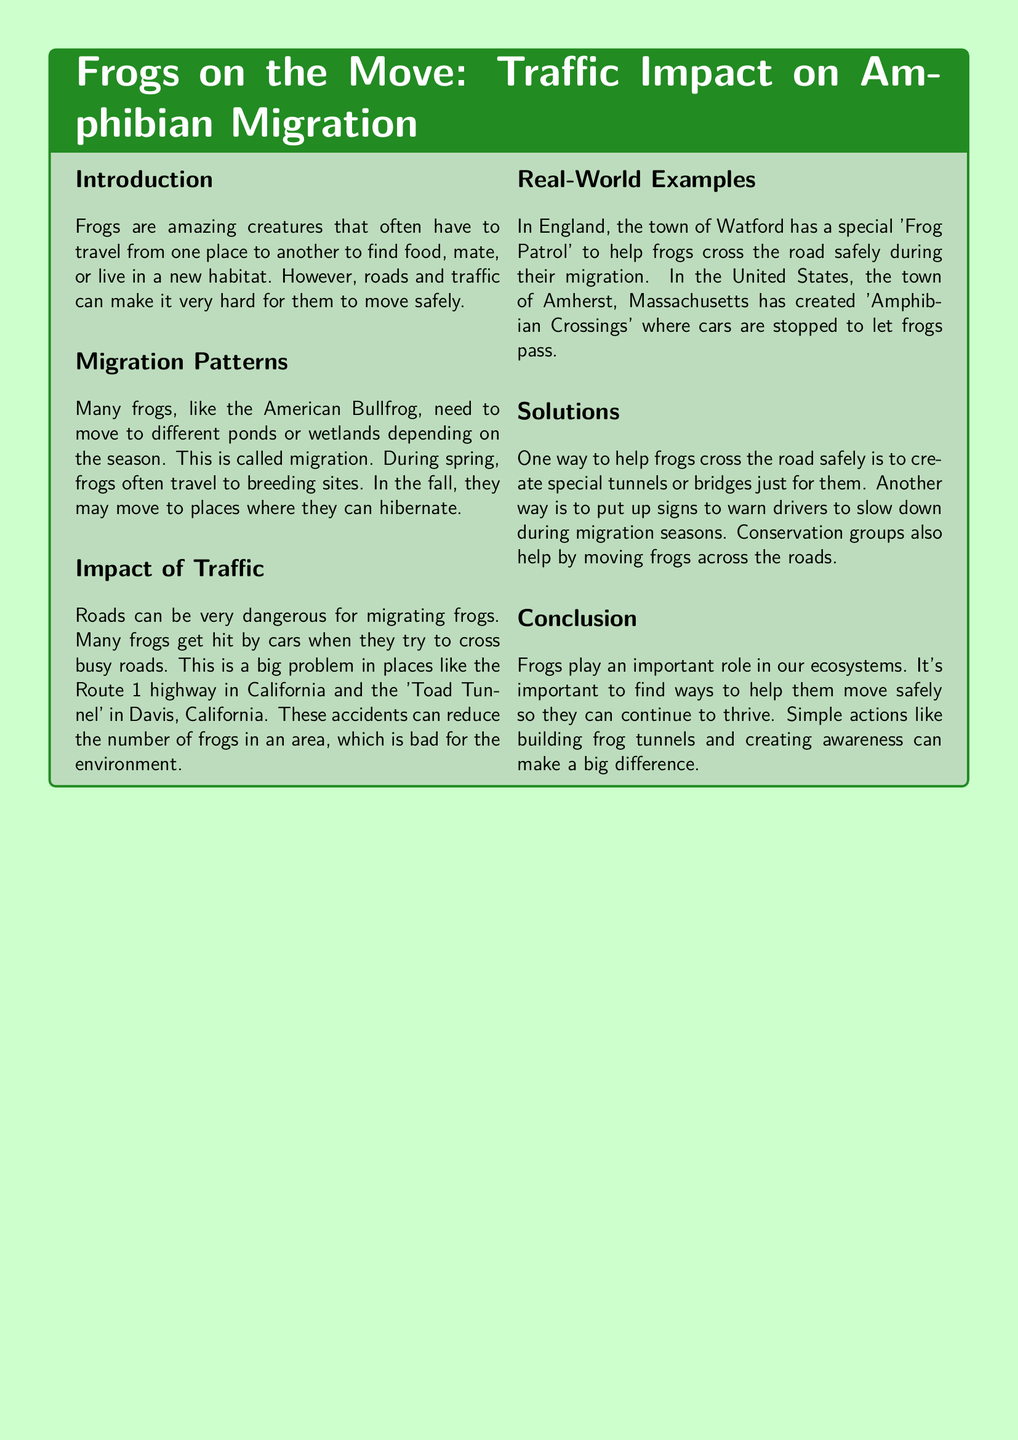what is the title of the report? The title of the report is explicitly stated in the document's header as "Frogs on the Move: Traffic Impact on Amphibian Migration."
Answer: Frogs on the Move: Traffic Impact on Amphibian Migration what do frogs need to find during their migration? The document mentions that frogs often need to find food, mate, or live in a new habitat during migration.
Answer: food, mate, or new habitat which frog is mentioned as migrating to different ponds? The document specifies the American Bullfrog as an example of a migrating frog.
Answer: American Bullfrog what is one major danger for migrating frogs? The report states that many frogs get hit by cars when they try to cross busy roads, highlighting this as a significant danger.
Answer: hit by cars where is a town with a special 'Frog Patrol'? The document identifies Watford in England as the town with a 'Frog Patrol.'
Answer: Watford what is one suggested solution for helping frogs cross roads? The document lists creating special tunnels or bridges just for frogs as one solution for safe crossing.
Answer: tunnels or bridges how does the report describe the impact of traffic on frogs? It explains that trafficked roads can reduce the number of frogs in an area, which negatively affects the environment.
Answer: reduces the number of frogs what does the 'Frog Patrol' do? The document indicates that the 'Frog Patrol' helps frogs cross the road safely during their migration.
Answer: helps frogs cross the road safely what season do frogs often breed? The document states that frogs often travel to breeding sites during spring.
Answer: spring 